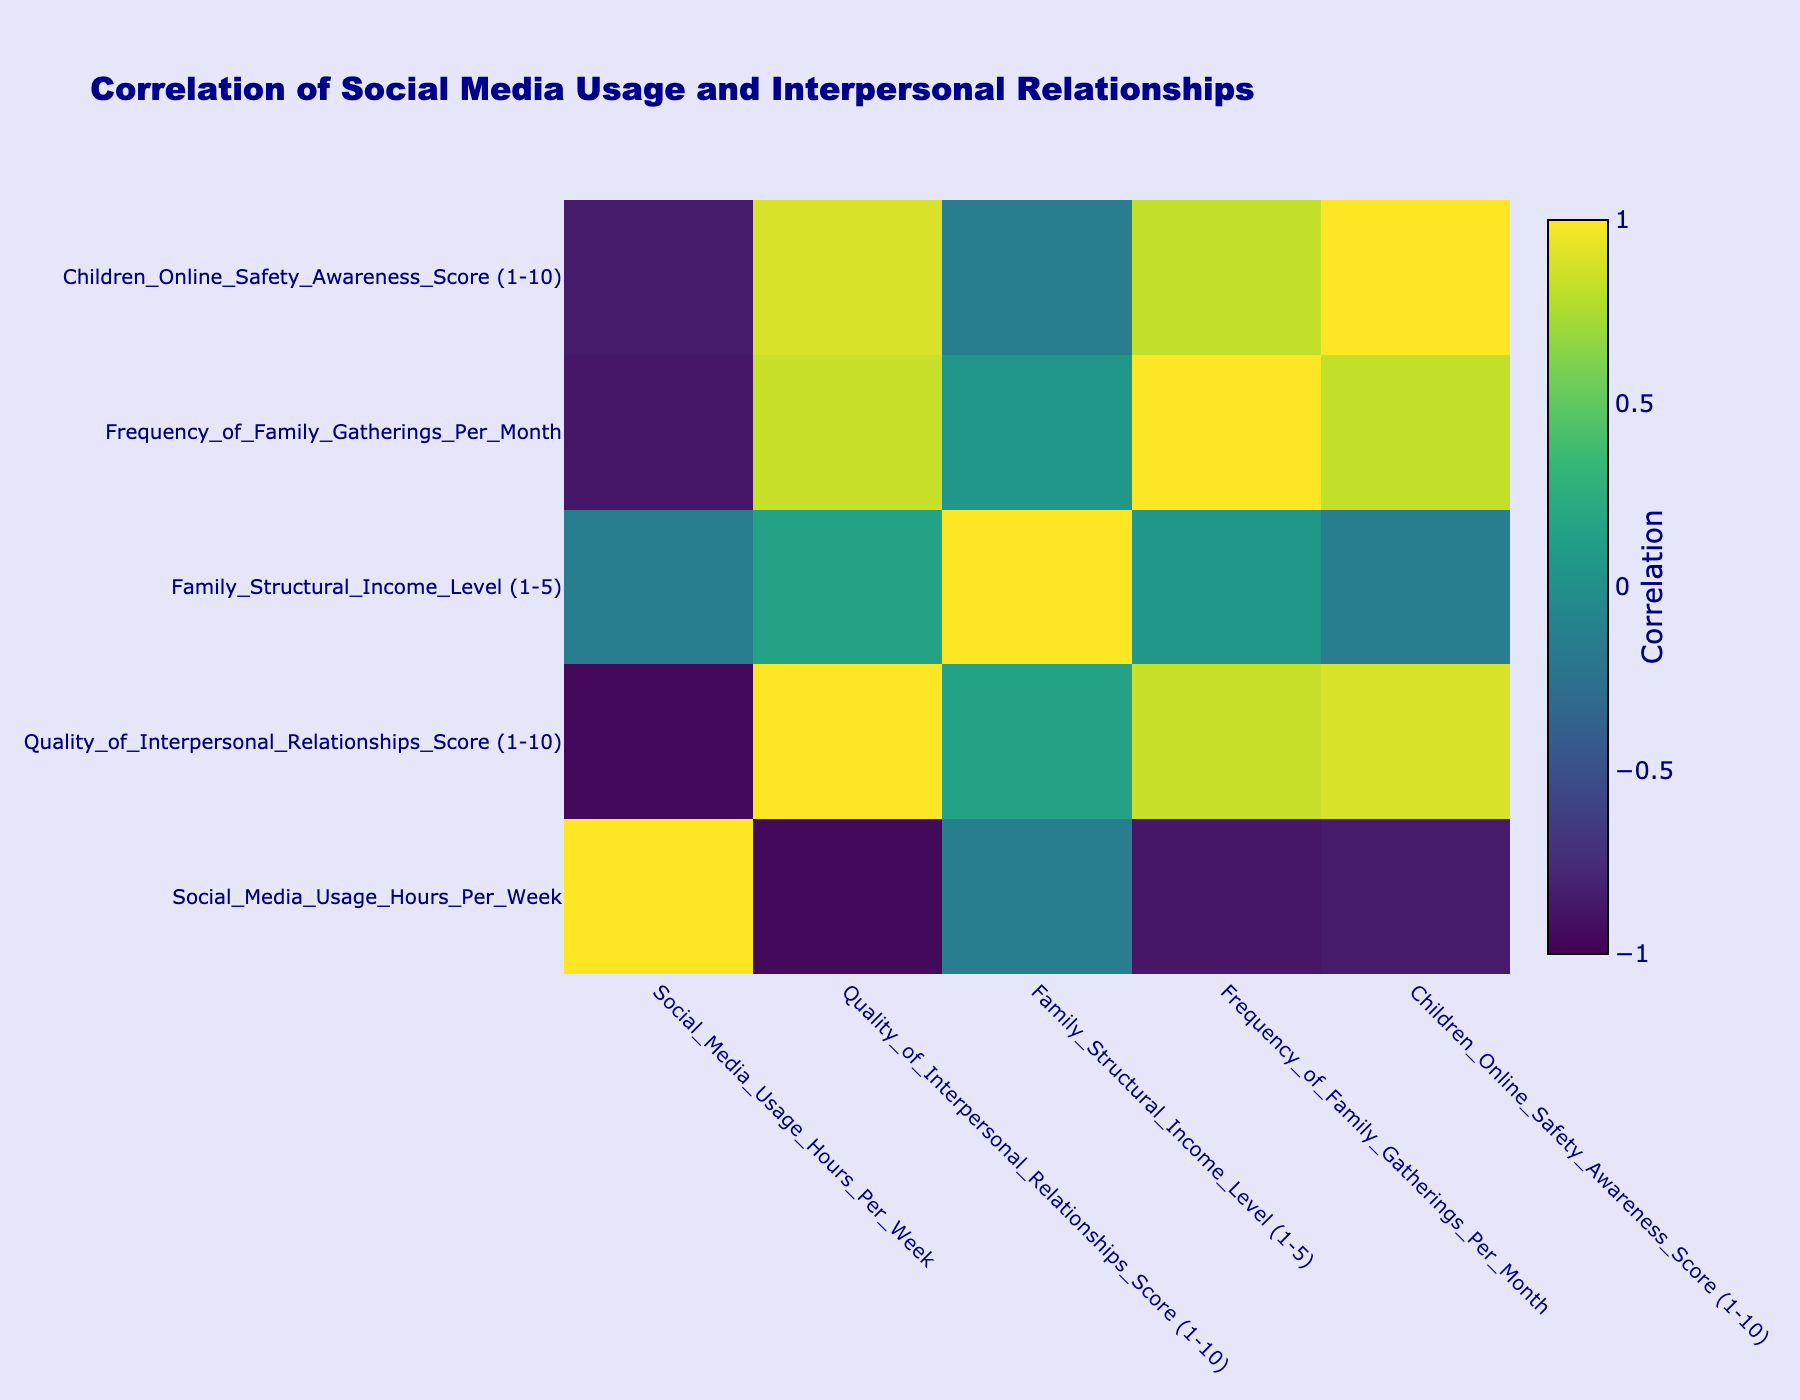What is the correlation between social media usage hours per week and the quality of interpersonal relationships score? To find this, we look for the correlation coefficient in the correlation table between "Social Media Usage Hours Per Week" and "Quality of Interpersonal Relationships Score". If we check the entry in the table, it indicates a negative correlation, which suggests that as social media usage increases, the quality of interpersonal relationships tends to decrease.
Answer: Negative correlation Which family has the highest score for the quality of interpersonal relationships? By scanning the "Quality of Interpersonal Relationships Score" column, we find that the family with the highest score is Miller with a score of 9.
Answer: Miller What is the average frequency of family gatherings per month across all families? To calculate this, we need to sum up the values in the "Frequency of Family Gatherings Per Month" column (2 + 4 + 1 + 3 + 2 + 5 + 0 + 3 + 2 + 6 = 28) and then divide it by the number of families (10). Therefore, the average is 28/10 = 2.8.
Answer: 2.8 Is there a family that uses social media for more than 20 hours per week and has a quality of interpersonal relationships score of 5 or below? Checking the entries, we find that both the Williams and Davis families use social media for more than 20 hours per week, and their corresponding quality scores are 5 and 4, respectively. Thus, both families meet the criteria.
Answer: Yes What is the average children's online safety awareness score for families that gather more than twice a month? First, we identify the families that gather more than twice a month (Smith, Brown, Miller, Anderson, Thomas). Their respective children's online safety awareness scores are 7, 5, 8, 7, and 9. The sum of these scores is 36, and there are 5 families, so we divide 36 by 5 to get the average: 36/5 = 7.2.
Answer: 7.2 How many families have a quality of interpersonal relationships score of 8 or more? Looking through the "Quality of Interpersonal Relationships Score" column, we find that the families with scores of 8 or more are Smith, Miller, and Anderson. Thus, there are 3 families.
Answer: 3 What is the structural income level of the family that has the lowest quality of interpersonal relationships score? Upon locating the minimum value in the "Quality of Interpersonal Relationships Score" column, we find that the family with the lowest score is Davis with a score of 4. Referring to the "Family Structural Income Level" column for Davis, we see it is a 5.
Answer: 5 Is there a positive correlation between the family structural income level and the quality of interpersonal relationships score among the families? The correlation table must be checked for the relationship between "Family Structural Income Level" and "Quality of Interpersonal Relationships Score". The coefficient will likely show a positive value if there is a correlation. After checking, we find that the correlation coefficient is positive, indicating that higher income levels are associated with higher relationship quality scores.
Answer: Yes 